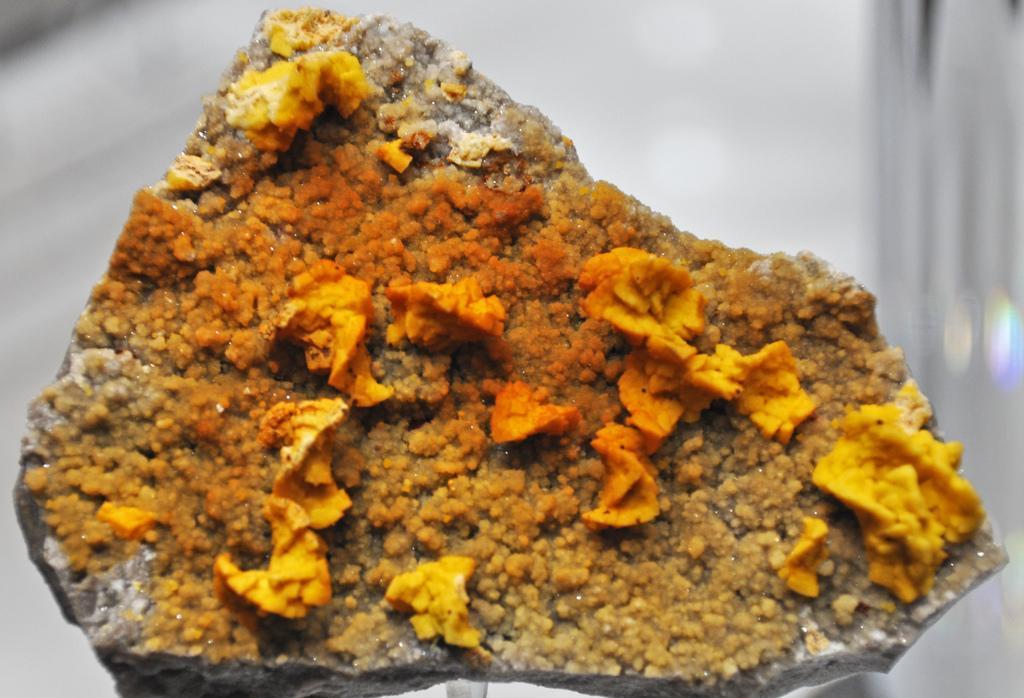Please provide a concise description of this image. In this image we can see food item. There is a white background. 